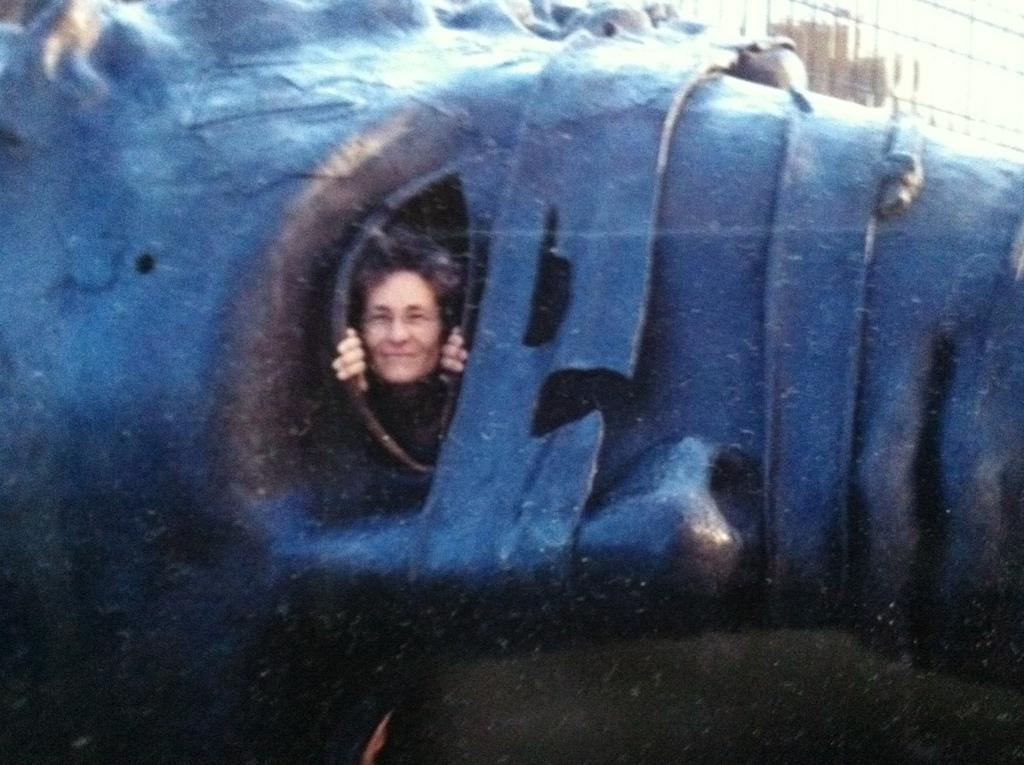What is the main subject of the image? There is a sculpture in the image. What color is the sculpture? The sculpture is blue in color. What feature does the sculpture have that resembles a human? The sculpture has a human face. What specific facial features can be seen on the sculpture? The face has eyes and a nose. Can you see a coil of wire in the image? There is no coil of wire present in the image; it features a blue sculpture with a human face. What type of weather is depicted in the image? The image does not depict any weather conditions, as it focuses on a sculpture with a human face. 